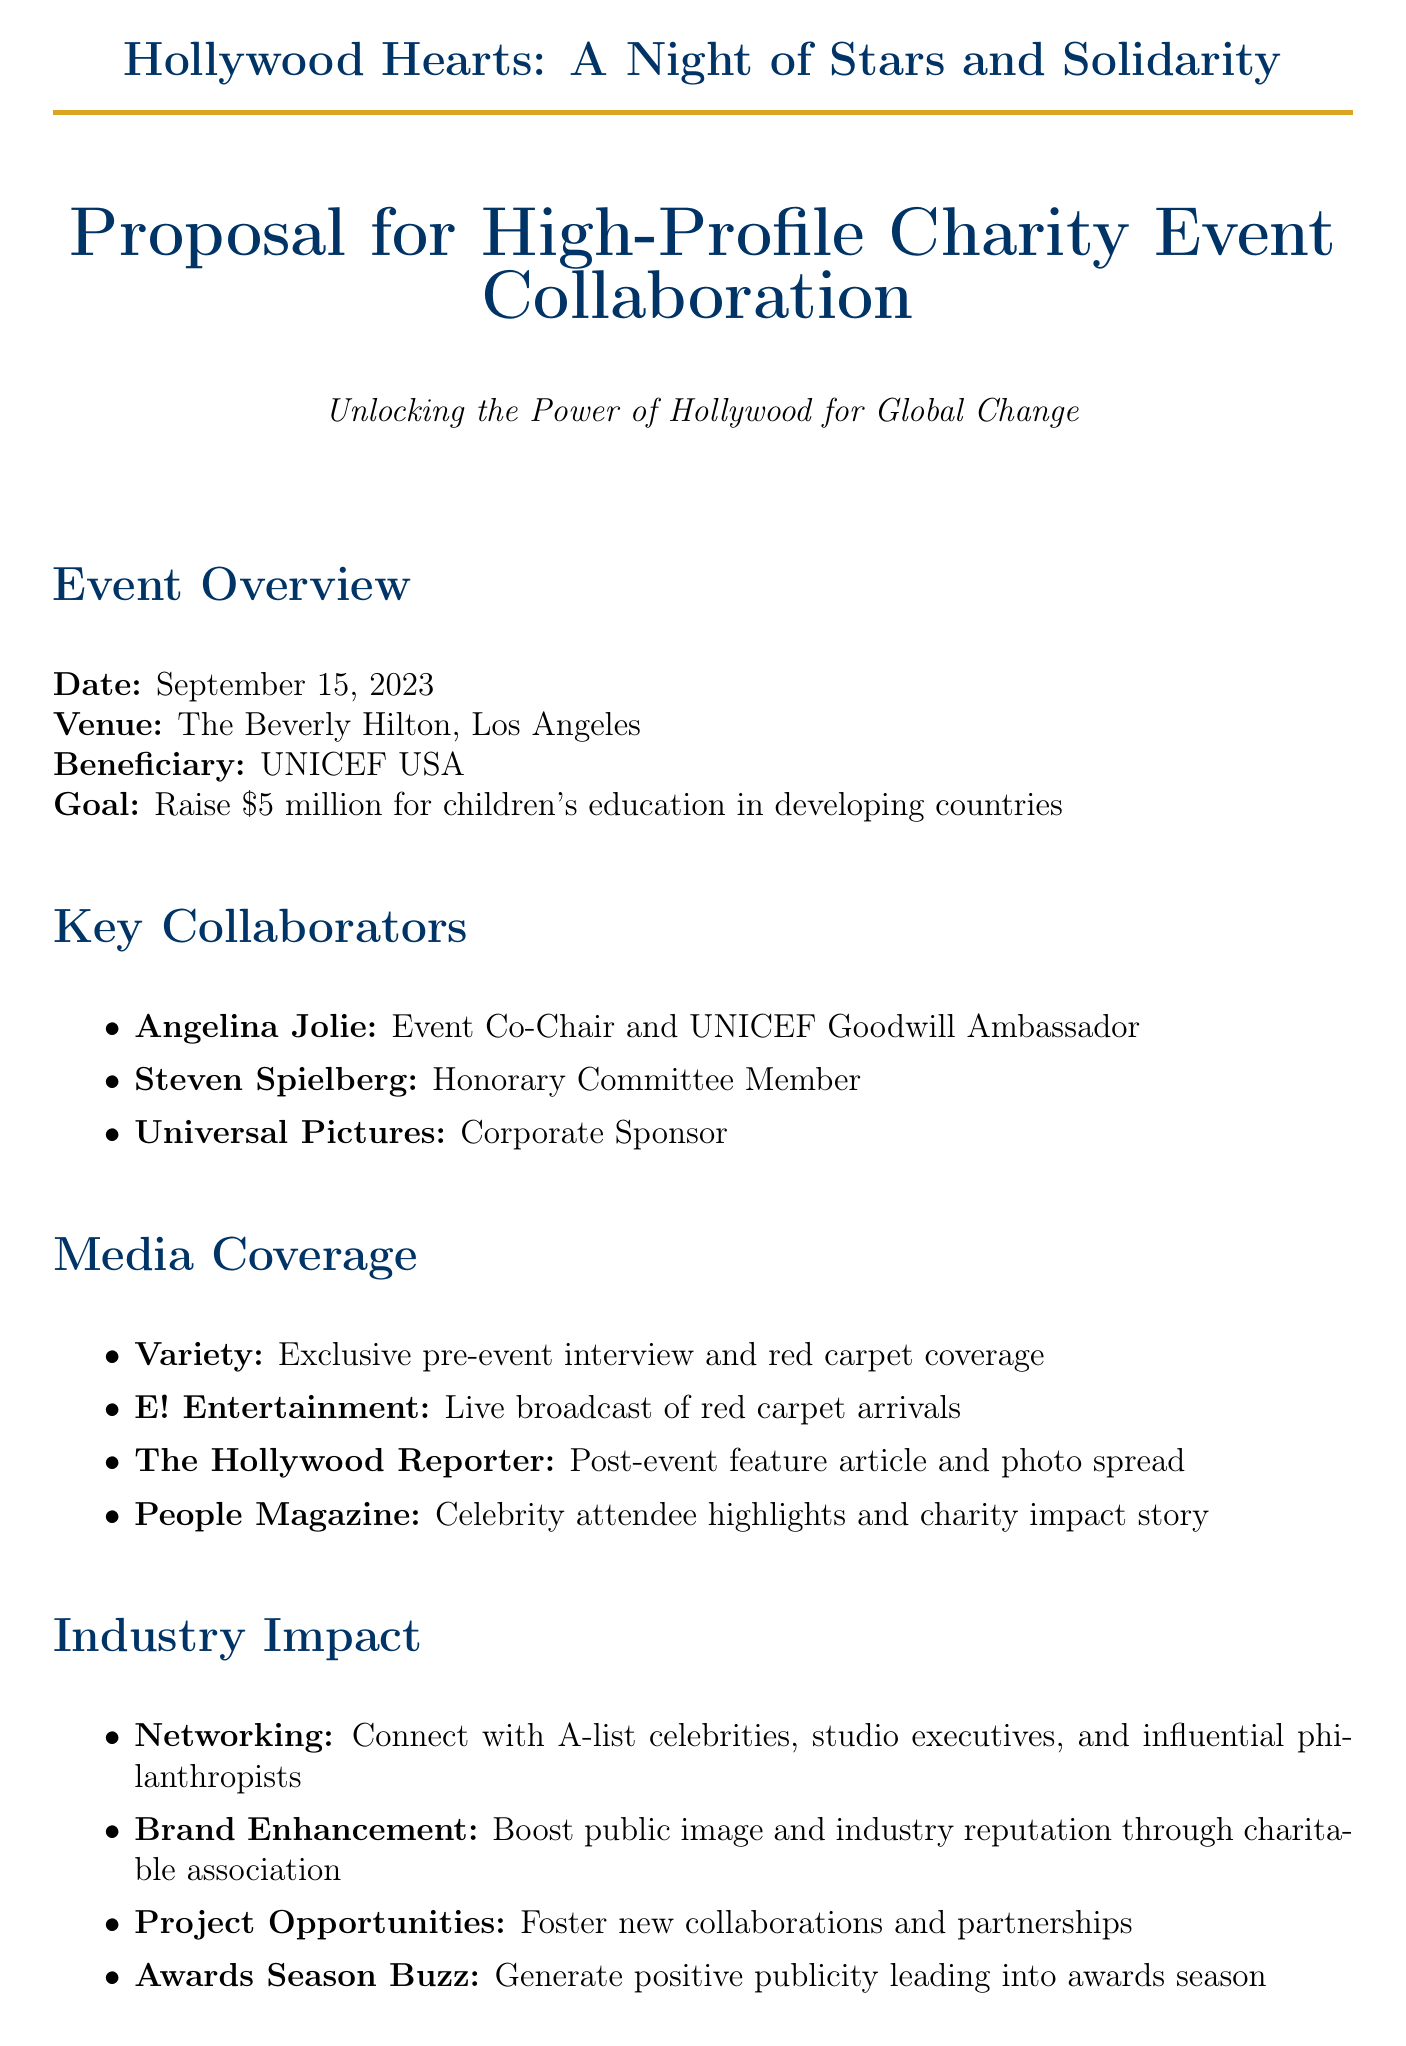What is the date of the event? The date of the event is stated clearly in the event overview section of the document.
Answer: September 15, 2023 Who is the event co-chair? The document specifies that Angelina Jolie is the event co-chair.
Answer: Angelina Jolie What is the fundraising goal? The document outlines the fundraising goal for the charity event in the event overview section.
Answer: Raise $5 million Which company is listed as a corporate sponsor? The document includes a section on key collaborators where Universal Pictures is mentioned as a corporate sponsor.
Answer: Universal Pictures What type of media coverage will Variety provide? Variety's role is detailed under the media coverage section of the document.
Answer: Exclusive pre-event interview and red carpet coverage What potential outcome involves the awards season? The expected outcomes section mentions a specific aspect related to awards season publicity.
Answer: Awards Season Buzz How does the event enhance public image? The document discusses brand enhancement under industry impact, highlighting the impact on public image.
Answer: Boosting public image What activity features a live performance? The event highlights section mentions a live performance by a Grammy-winning artist.
Answer: Live Performance Who is delivering the keynote speech? The document states in the event highlights section that the keynote speech will be delivered by a well-known figure.
Answer: Barack Obama 